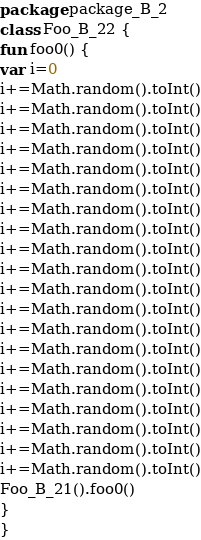Convert code to text. <code><loc_0><loc_0><loc_500><loc_500><_Kotlin_>package package_B_2
class Foo_B_22 {
fun foo0() {
var i=0
i+=Math.random().toInt()
i+=Math.random().toInt()
i+=Math.random().toInt()
i+=Math.random().toInt()
i+=Math.random().toInt()
i+=Math.random().toInt()
i+=Math.random().toInt()
i+=Math.random().toInt()
i+=Math.random().toInt()
i+=Math.random().toInt()
i+=Math.random().toInt()
i+=Math.random().toInt()
i+=Math.random().toInt()
i+=Math.random().toInt()
i+=Math.random().toInt()
i+=Math.random().toInt()
i+=Math.random().toInt()
i+=Math.random().toInt()
i+=Math.random().toInt()
i+=Math.random().toInt()
Foo_B_21().foo0()
}
}</code> 